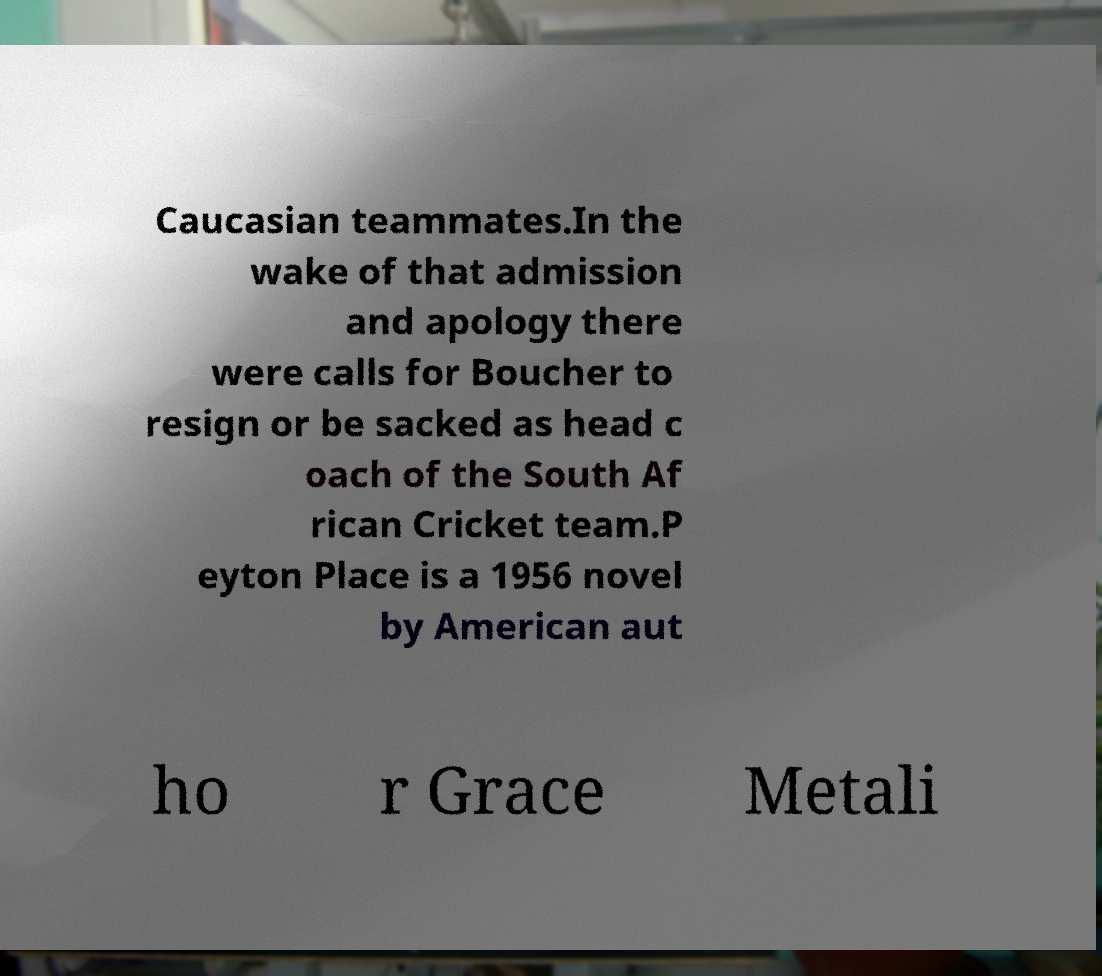Can you accurately transcribe the text from the provided image for me? Caucasian teammates.In the wake of that admission and apology there were calls for Boucher to resign or be sacked as head c oach of the South Af rican Cricket team.P eyton Place is a 1956 novel by American aut ho r Grace Metali 